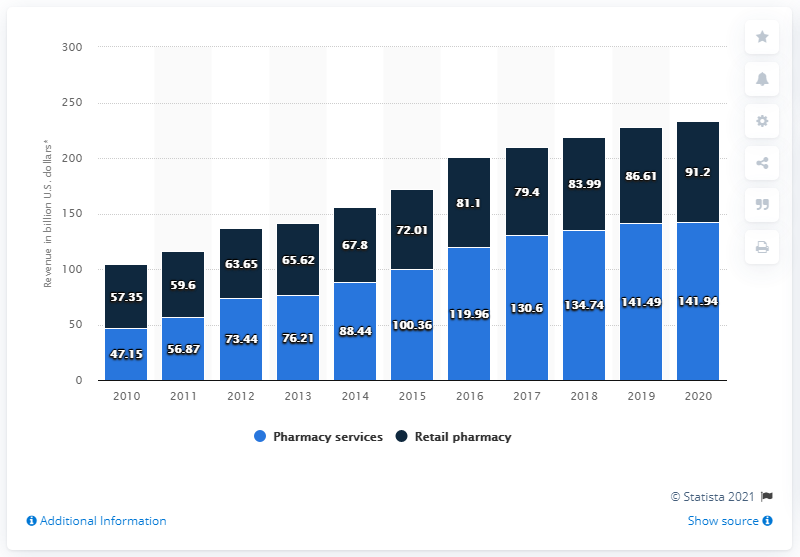Mention a couple of crucial points in this snapshot. In 2014, CVS changed its name from CVS Caremark to CVS Health. In 2020, CVS Health's pharmacy services segment generated approximately 141.94 million U.S. dollars in revenue. 